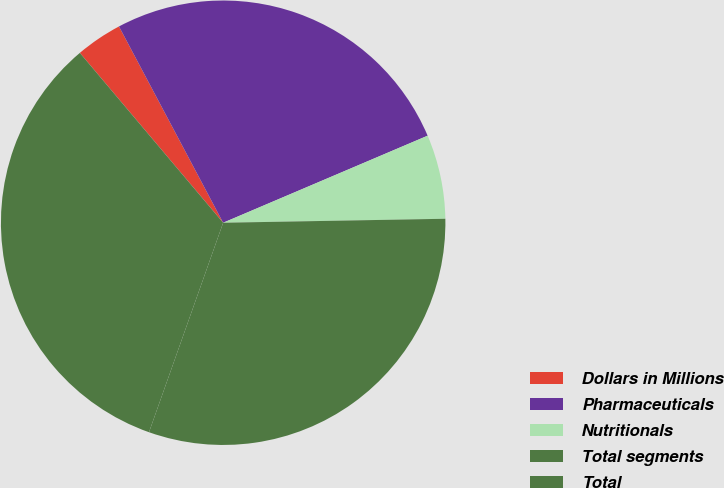Convert chart to OTSL. <chart><loc_0><loc_0><loc_500><loc_500><pie_chart><fcel>Dollars in Millions<fcel>Pharmaceuticals<fcel>Nutritionals<fcel>Total segments<fcel>Total<nl><fcel>3.39%<fcel>26.36%<fcel>6.12%<fcel>30.7%<fcel>33.43%<nl></chart> 